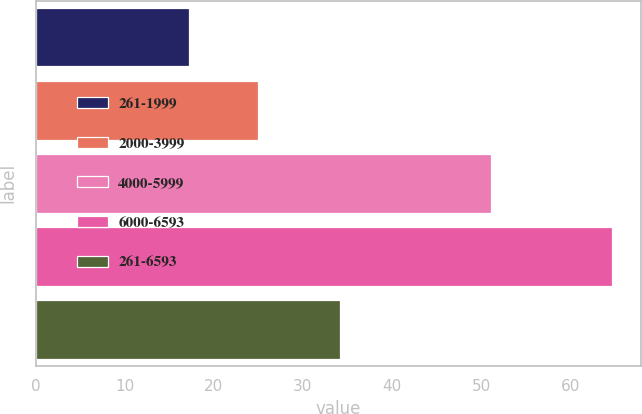<chart> <loc_0><loc_0><loc_500><loc_500><bar_chart><fcel>261-1999<fcel>2000-3999<fcel>4000-5999<fcel>6000-6593<fcel>261-6593<nl><fcel>17.16<fcel>24.95<fcel>51.15<fcel>64.67<fcel>34.17<nl></chart> 